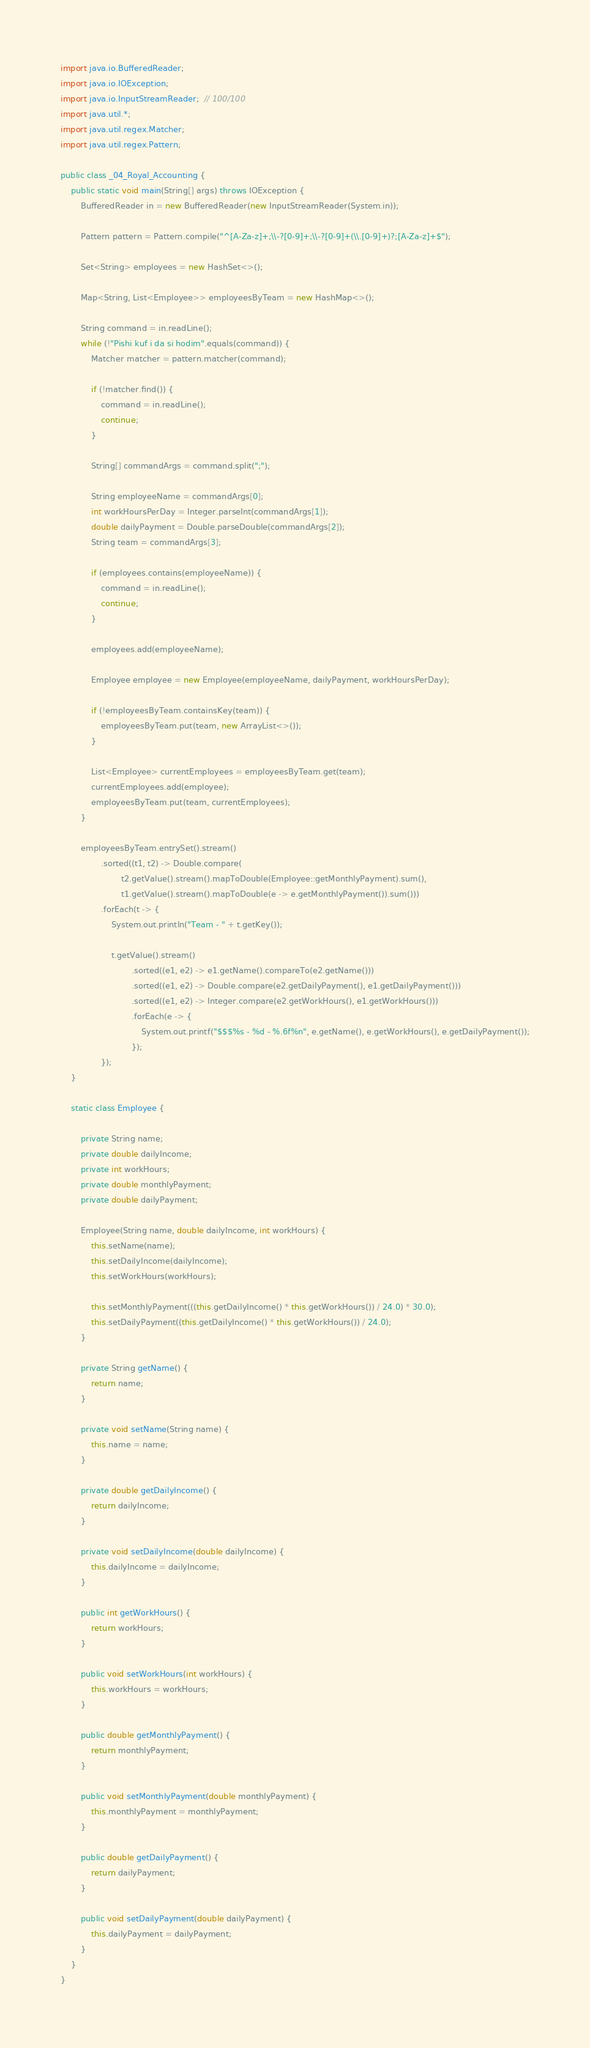<code> <loc_0><loc_0><loc_500><loc_500><_Java_>import java.io.BufferedReader;
import java.io.IOException;
import java.io.InputStreamReader;  // 100/100
import java.util.*;
import java.util.regex.Matcher;
import java.util.regex.Pattern;

public class _04_Royal_Accounting {
    public static void main(String[] args) throws IOException {
        BufferedReader in = new BufferedReader(new InputStreamReader(System.in));

        Pattern pattern = Pattern.compile("^[A-Za-z]+;\\-?[0-9]+;\\-?[0-9]+(\\.[0-9]+)?;[A-Za-z]+$");

        Set<String> employees = new HashSet<>();

        Map<String, List<Employee>> employeesByTeam = new HashMap<>();

        String command = in.readLine();
        while (!"Pishi kuf i da si hodim".equals(command)) {
            Matcher matcher = pattern.matcher(command);

            if (!matcher.find()) {
                command = in.readLine();
                continue;
            }

            String[] commandArgs = command.split(";");

            String employeeName = commandArgs[0];
            int workHoursPerDay = Integer.parseInt(commandArgs[1]);
            double dailyPayment = Double.parseDouble(commandArgs[2]);
            String team = commandArgs[3];

            if (employees.contains(employeeName)) {
                command = in.readLine();
                continue;
            }

            employees.add(employeeName);

            Employee employee = new Employee(employeeName, dailyPayment, workHoursPerDay);

            if (!employeesByTeam.containsKey(team)) {
                employeesByTeam.put(team, new ArrayList<>());
            }

            List<Employee> currentEmployees = employeesByTeam.get(team);
            currentEmployees.add(employee);
            employeesByTeam.put(team, currentEmployees);
        }

        employeesByTeam.entrySet().stream()
                .sorted((t1, t2) -> Double.compare(
                        t2.getValue().stream().mapToDouble(Employee::getMonthlyPayment).sum(),
                        t1.getValue().stream().mapToDouble(e -> e.getMonthlyPayment()).sum()))
                .forEach(t -> {
                    System.out.println("Team - " + t.getKey());

                    t.getValue().stream()
                            .sorted((e1, e2) -> e1.getName().compareTo(e2.getName()))
                            .sorted((e1, e2) -> Double.compare(e2.getDailyPayment(), e1.getDailyPayment()))
                            .sorted((e1, e2) -> Integer.compare(e2.getWorkHours(), e1.getWorkHours()))
                            .forEach(e -> {
                                System.out.printf("$$$%s - %d - %.6f%n", e.getName(), e.getWorkHours(), e.getDailyPayment());
                            });
                });
    }

    static class Employee {

        private String name;
        private double dailyIncome;
        private int workHours;
        private double monthlyPayment;
        private double dailyPayment;

        Employee(String name, double dailyIncome, int workHours) {
            this.setName(name);
            this.setDailyIncome(dailyIncome);
            this.setWorkHours(workHours);

            this.setMonthlyPayment(((this.getDailyIncome() * this.getWorkHours()) / 24.0) * 30.0);
            this.setDailyPayment((this.getDailyIncome() * this.getWorkHours()) / 24.0);
        }

        private String getName() {
            return name;
        }

        private void setName(String name) {
            this.name = name;
        }

        private double getDailyIncome() {
            return dailyIncome;
        }

        private void setDailyIncome(double dailyIncome) {
            this.dailyIncome = dailyIncome;
        }

        public int getWorkHours() {
            return workHours;
        }

        public void setWorkHours(int workHours) {
            this.workHours = workHours;
        }

        public double getMonthlyPayment() {
            return monthlyPayment;
        }

        public void setMonthlyPayment(double monthlyPayment) {
            this.monthlyPayment = monthlyPayment;
        }

        public double getDailyPayment() {
            return dailyPayment;
        }

        public void setDailyPayment(double dailyPayment) {
            this.dailyPayment = dailyPayment;
        }
    }
}
</code> 